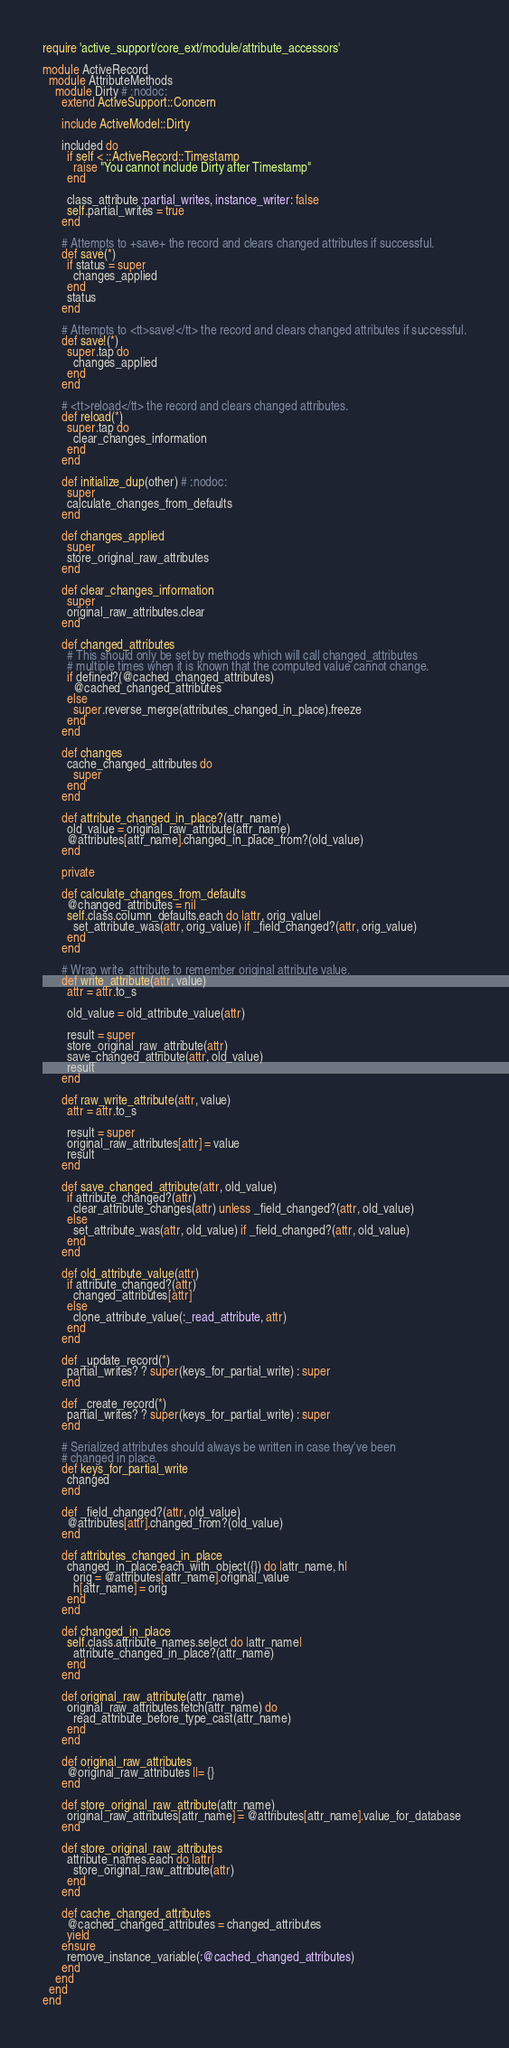Convert code to text. <code><loc_0><loc_0><loc_500><loc_500><_Ruby_>require 'active_support/core_ext/module/attribute_accessors'

module ActiveRecord
  module AttributeMethods
    module Dirty # :nodoc:
      extend ActiveSupport::Concern

      include ActiveModel::Dirty

      included do
        if self < ::ActiveRecord::Timestamp
          raise "You cannot include Dirty after Timestamp"
        end

        class_attribute :partial_writes, instance_writer: false
        self.partial_writes = true
      end

      # Attempts to +save+ the record and clears changed attributes if successful.
      def save(*)
        if status = super
          changes_applied
        end
        status
      end

      # Attempts to <tt>save!</tt> the record and clears changed attributes if successful.
      def save!(*)
        super.tap do
          changes_applied
        end
      end

      # <tt>reload</tt> the record and clears changed attributes.
      def reload(*)
        super.tap do
          clear_changes_information
        end
      end

      def initialize_dup(other) # :nodoc:
        super
        calculate_changes_from_defaults
      end

      def changes_applied
        super
        store_original_raw_attributes
      end

      def clear_changes_information
        super
        original_raw_attributes.clear
      end

      def changed_attributes
        # This should only be set by methods which will call changed_attributes
        # multiple times when it is known that the computed value cannot change.
        if defined?(@cached_changed_attributes)
          @cached_changed_attributes
        else
          super.reverse_merge(attributes_changed_in_place).freeze
        end
      end

      def changes
        cache_changed_attributes do
          super
        end
      end

      def attribute_changed_in_place?(attr_name)
        old_value = original_raw_attribute(attr_name)
        @attributes[attr_name].changed_in_place_from?(old_value)
      end

      private

      def calculate_changes_from_defaults
        @changed_attributes = nil
        self.class.column_defaults.each do |attr, orig_value|
          set_attribute_was(attr, orig_value) if _field_changed?(attr, orig_value)
        end
      end

      # Wrap write_attribute to remember original attribute value.
      def write_attribute(attr, value)
        attr = attr.to_s

        old_value = old_attribute_value(attr)

        result = super
        store_original_raw_attribute(attr)
        save_changed_attribute(attr, old_value)
        result
      end

      def raw_write_attribute(attr, value)
        attr = attr.to_s

        result = super
        original_raw_attributes[attr] = value
        result
      end

      def save_changed_attribute(attr, old_value)
        if attribute_changed?(attr)
          clear_attribute_changes(attr) unless _field_changed?(attr, old_value)
        else
          set_attribute_was(attr, old_value) if _field_changed?(attr, old_value)
        end
      end

      def old_attribute_value(attr)
        if attribute_changed?(attr)
          changed_attributes[attr]
        else
          clone_attribute_value(:_read_attribute, attr)
        end
      end

      def _update_record(*)
        partial_writes? ? super(keys_for_partial_write) : super
      end

      def _create_record(*)
        partial_writes? ? super(keys_for_partial_write) : super
      end

      # Serialized attributes should always be written in case they've been
      # changed in place.
      def keys_for_partial_write
        changed
      end

      def _field_changed?(attr, old_value)
        @attributes[attr].changed_from?(old_value)
      end

      def attributes_changed_in_place
        changed_in_place.each_with_object({}) do |attr_name, h|
          orig = @attributes[attr_name].original_value
          h[attr_name] = orig
        end
      end

      def changed_in_place
        self.class.attribute_names.select do |attr_name|
          attribute_changed_in_place?(attr_name)
        end
      end

      def original_raw_attribute(attr_name)
        original_raw_attributes.fetch(attr_name) do
          read_attribute_before_type_cast(attr_name)
        end
      end

      def original_raw_attributes
        @original_raw_attributes ||= {}
      end

      def store_original_raw_attribute(attr_name)
        original_raw_attributes[attr_name] = @attributes[attr_name].value_for_database
      end

      def store_original_raw_attributes
        attribute_names.each do |attr|
          store_original_raw_attribute(attr)
        end
      end

      def cache_changed_attributes
        @cached_changed_attributes = changed_attributes
        yield
      ensure
        remove_instance_variable(:@cached_changed_attributes)
      end
    end
  end
end
</code> 